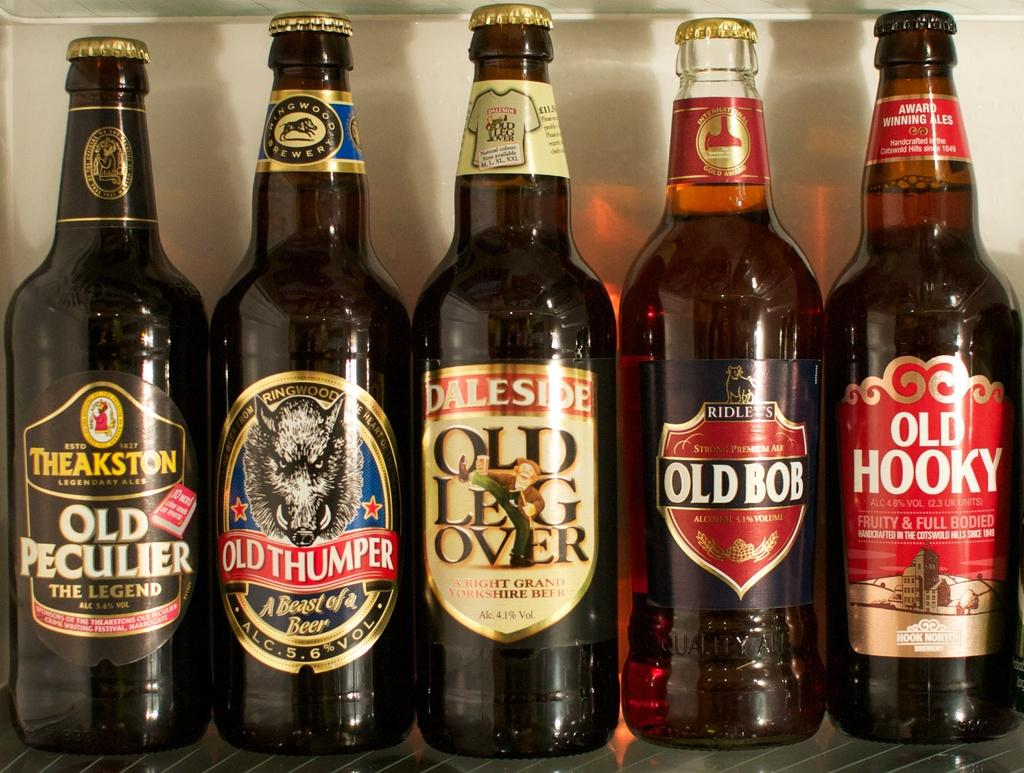<image>
Render a clear and concise summary of the photo. five bottles of beer that have not been opened 